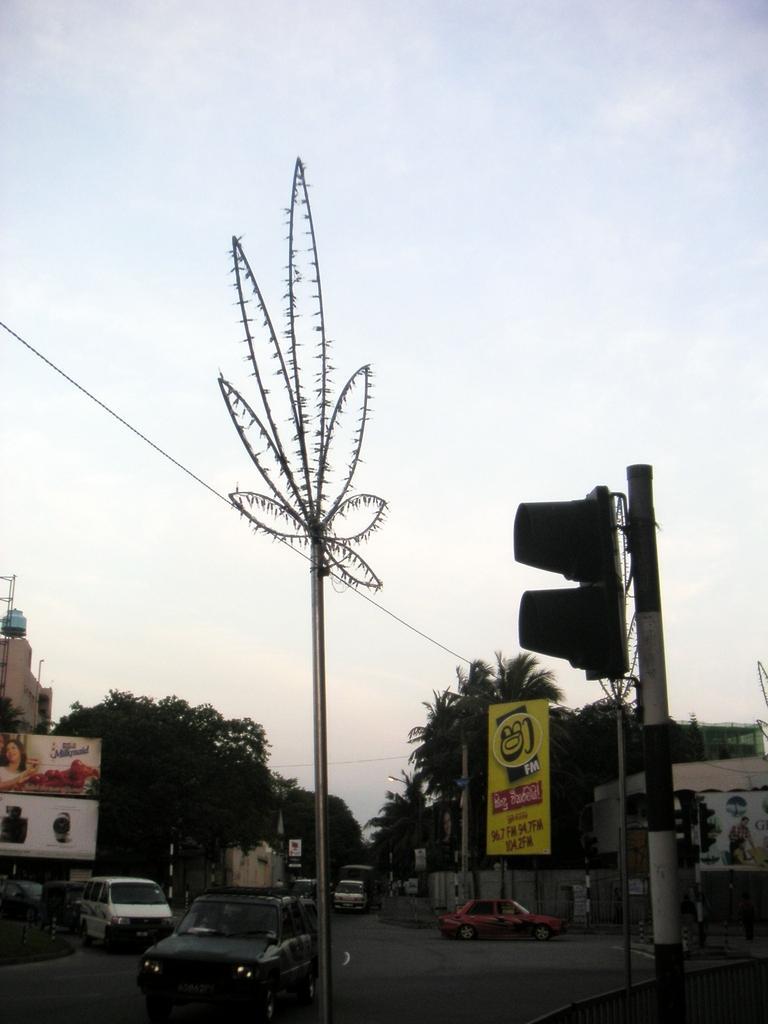Could you give a brief overview of what you see in this image? In this image, we can see some cars on the road. There are trees beside the road. There is a signal pole in the bottom right of the image. There is a hoarding in the bottom left of the image. There is a pole at the bottom of the image. In the background of the image, there is a sky. 